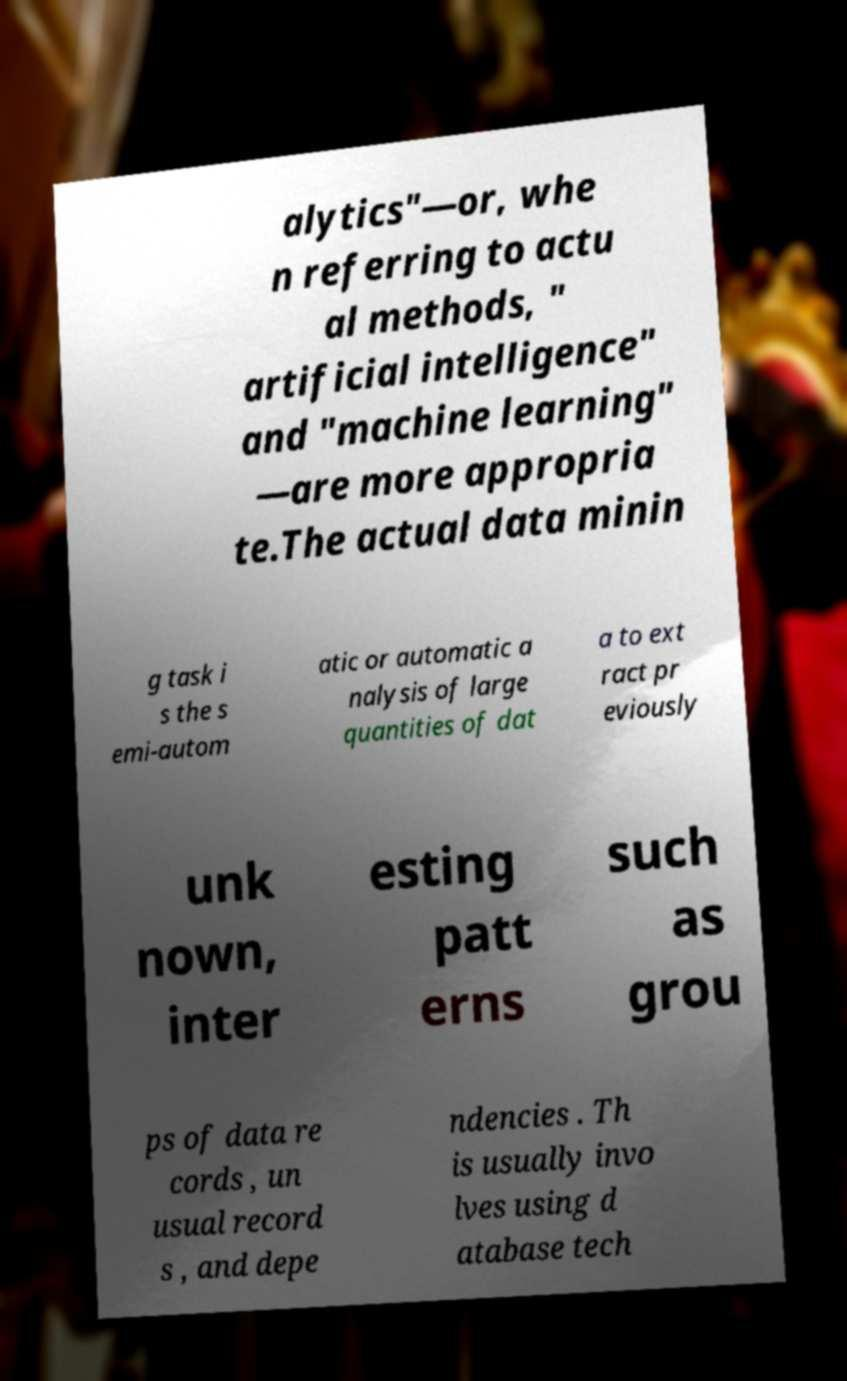For documentation purposes, I need the text within this image transcribed. Could you provide that? alytics"—or, whe n referring to actu al methods, " artificial intelligence" and "machine learning" —are more appropria te.The actual data minin g task i s the s emi-autom atic or automatic a nalysis of large quantities of dat a to ext ract pr eviously unk nown, inter esting patt erns such as grou ps of data re cords , un usual record s , and depe ndencies . Th is usually invo lves using d atabase tech 